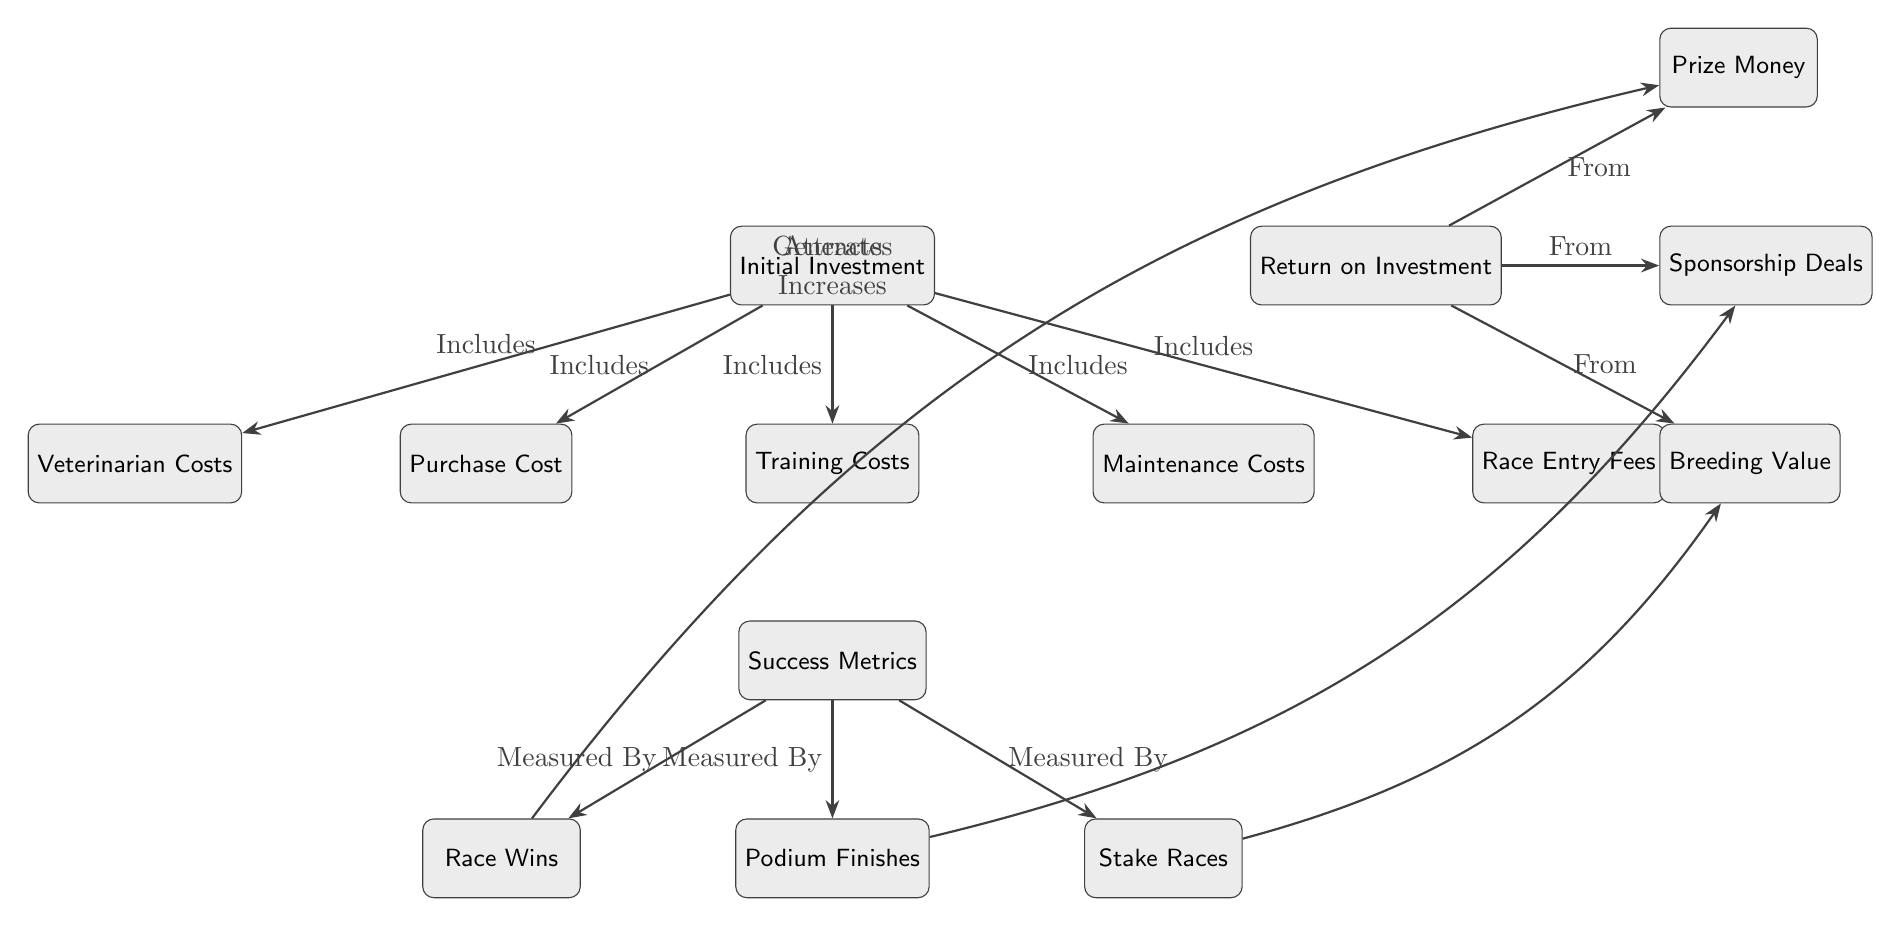What is the primary input in this investment analysis? The primary input in this analysis is the "Initial Investment" node, which is the starting point for all costs and metrics involved in racehorse investment.
Answer: Initial Investment How many success metrics are mentioned in the diagram? There are three success metrics visually represented in the diagram: "Race Wins," "Podium Finishes," and "Stake Races." Each of these nodes shows a specific way to measure success in horse racing.
Answer: 3 What costs are included in the "Initial Investment"? The "Initial Investment" includes the "Purchase Cost," "Training Costs," "Maintenance Costs," "Veterinarian Costs," and "Race Entry Fees." These are all the costs that contribute to the total investment.
Answer: Purchase Cost, Training Costs, Maintenance Costs, Veterinarian Costs, Race Entry Fees Which success metric is associated with generating prize money? The success metric "Race Wins" is associated with generating "Prize Money," indicating that winning races directly contributes to the earnings one can expect from racing activities.
Answer: Race Wins What leads to an increase in breeding value? "Stake Races" is the success metric that leads to an increase in "Breeding Value," showing that success in stake races can enhance the horse's breeding potential and market value.
Answer: Stake Races What are the three sources of return on investment? The three sources of return on investment are "Prize Money," "Sponsorship Deals," and "Breeding Value." Each of these nodes reflects different ways through which financial returns can be generated from the initial investment.
Answer: Prize Money, Sponsorship Deals, Breeding Value Which success metric attracts sponsorship? The "Podium Finishes" metric is associated with attracting "Sponsorship Deals," suggesting that consistently finishing in podium positions can draw sponsorship opportunities for the racehorse.
Answer: Podium Finishes What relationship exists between race wins and prize money? The relationship indicates that race wins generate prize money, indicating a direct link between achieving victories in races and potential financial rewards from those wins.
Answer: Generates How many total nodes are in the diagram? There are a total of twelve nodes in the diagram: five cost-related nodes, three success metrics, three return sources, and one initial investment.
Answer: 12 